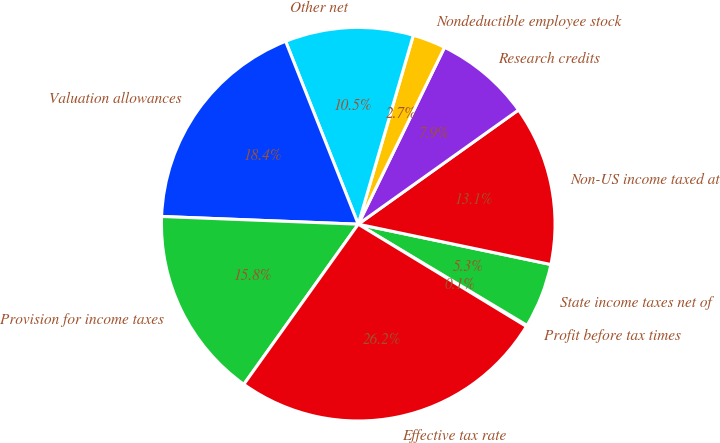Convert chart to OTSL. <chart><loc_0><loc_0><loc_500><loc_500><pie_chart><fcel>Profit before tax times<fcel>State income taxes net of<fcel>Non-US income taxed at<fcel>Research credits<fcel>Nondeductible employee stock<fcel>Other net<fcel>Valuation allowances<fcel>Provision for income taxes<fcel>Effective tax rate<nl><fcel>0.1%<fcel>5.31%<fcel>13.14%<fcel>7.92%<fcel>2.71%<fcel>10.53%<fcel>18.36%<fcel>15.75%<fcel>26.18%<nl></chart> 